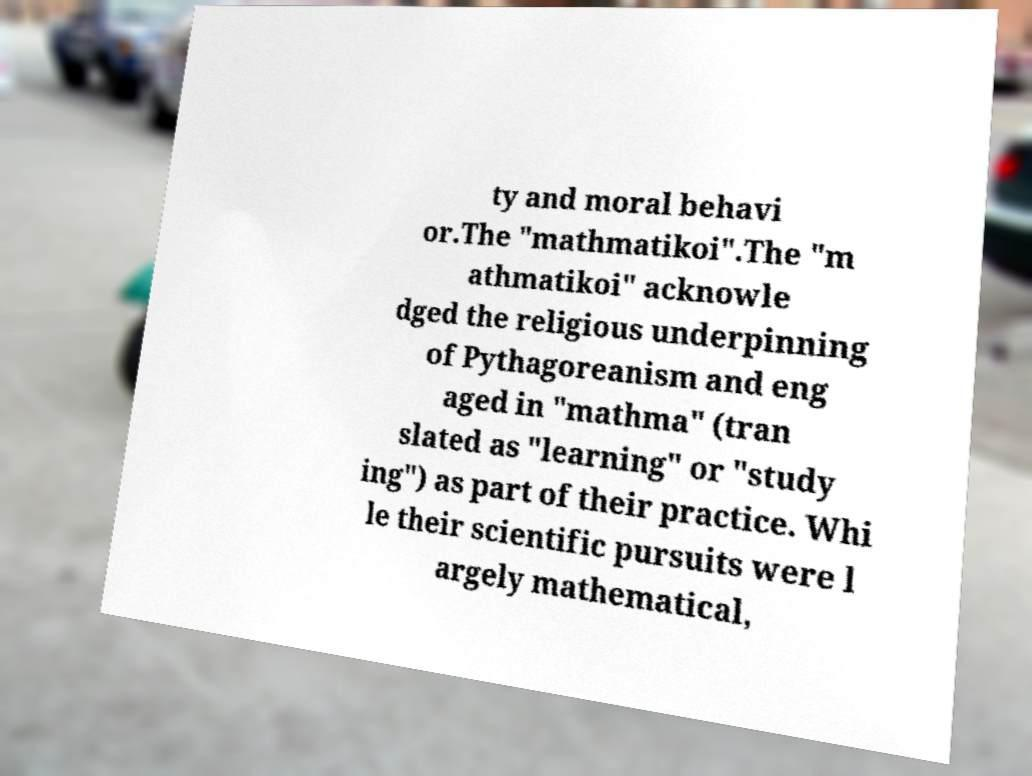Could you extract and type out the text from this image? ty and moral behavi or.The "mathmatikoi".The "m athmatikoi" acknowle dged the religious underpinning of Pythagoreanism and eng aged in "mathma" (tran slated as "learning" or "study ing") as part of their practice. Whi le their scientific pursuits were l argely mathematical, 